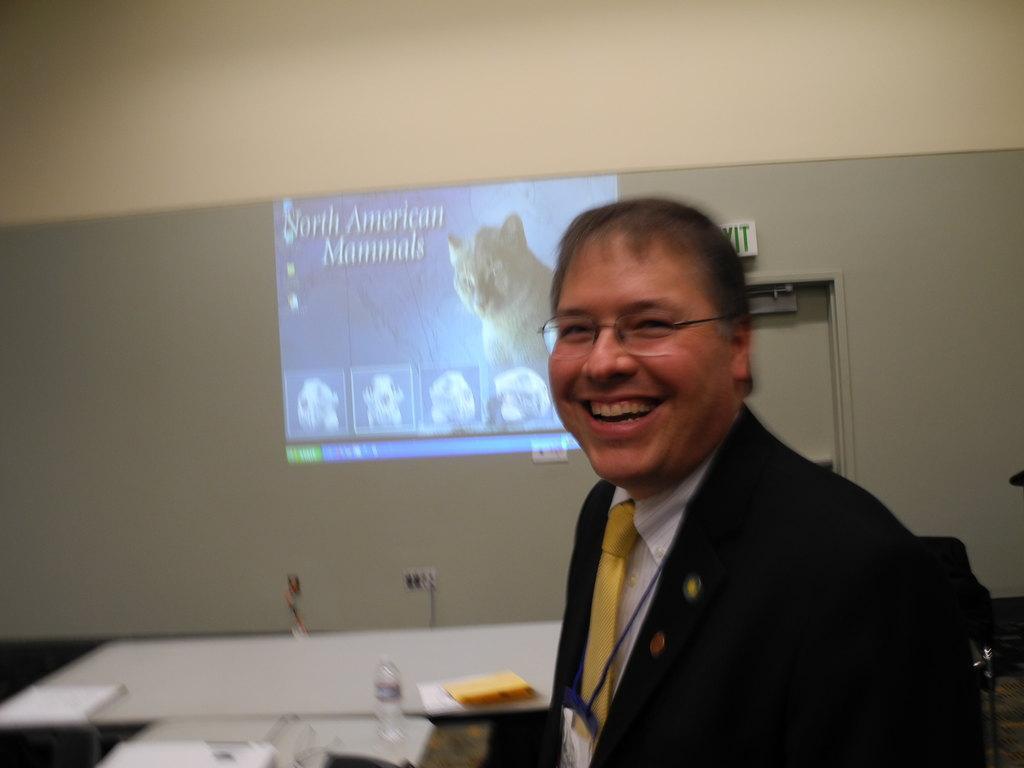Could you give a brief overview of what you see in this image? This is an image clicked inside the room. On the right side there is a person wearing black color suit and smiling by looking at the picture. In the background there is a screen and a table. On the table few papers and one bottle are placed. 